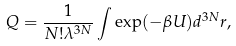<formula> <loc_0><loc_0><loc_500><loc_500>Q = \frac { 1 } { N ! \lambda ^ { 3 N } } \int \exp ( - \beta U ) d ^ { 3 N } r ,</formula> 